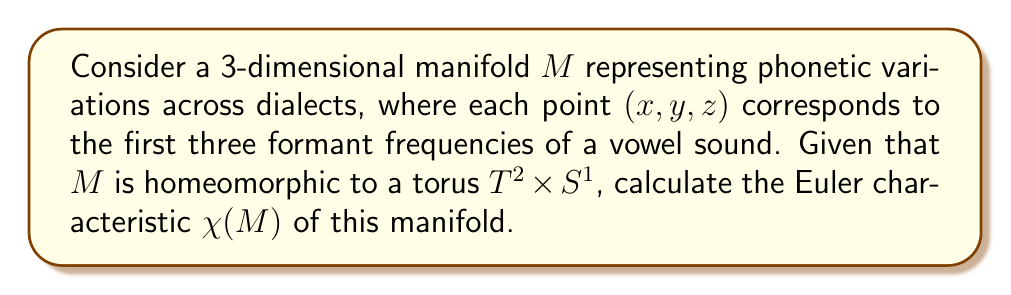Could you help me with this problem? To solve this problem, we'll follow these steps:

1) First, recall that the Euler characteristic is a topological invariant. This means that if two spaces are homeomorphic, they have the same Euler characteristic.

2) We're given that $M$ is homeomorphic to $T^2 \times S^1$, where $T^2$ is a 2-torus and $S^1$ is a circle. So, $\chi(M) = \chi(T^2 \times S^1)$.

3) Next, we'll use the product formula for Euler characteristics:

   For any two topological spaces $X$ and $Y$, $\chi(X \times Y) = \chi(X) \cdot \chi(Y)$

4) So, we need to calculate $\chi(T^2)$ and $\chi(S^1)$ separately:

   a) For $S^1$ (a circle): $\chi(S^1) = 0$
      (A circle can be triangulated with one 0-simplex and one 1-simplex, so $\chi = 1 - 1 = 0$)

   b) For $T^2$ (a 2-torus): $\chi(T^2) = 0$
      (This is a well-known result, but can be derived using the formula $\chi = V - E + F$ for a suitable triangulation of the torus)

5) Now we can apply the product formula:

   $$\chi(M) = \chi(T^2 \times S^1) = \chi(T^2) \cdot \chi(S^1) = 0 \cdot 0 = 0$$

Therefore, the Euler characteristic of the manifold $M$ is 0.
Answer: $\chi(M) = 0$ 